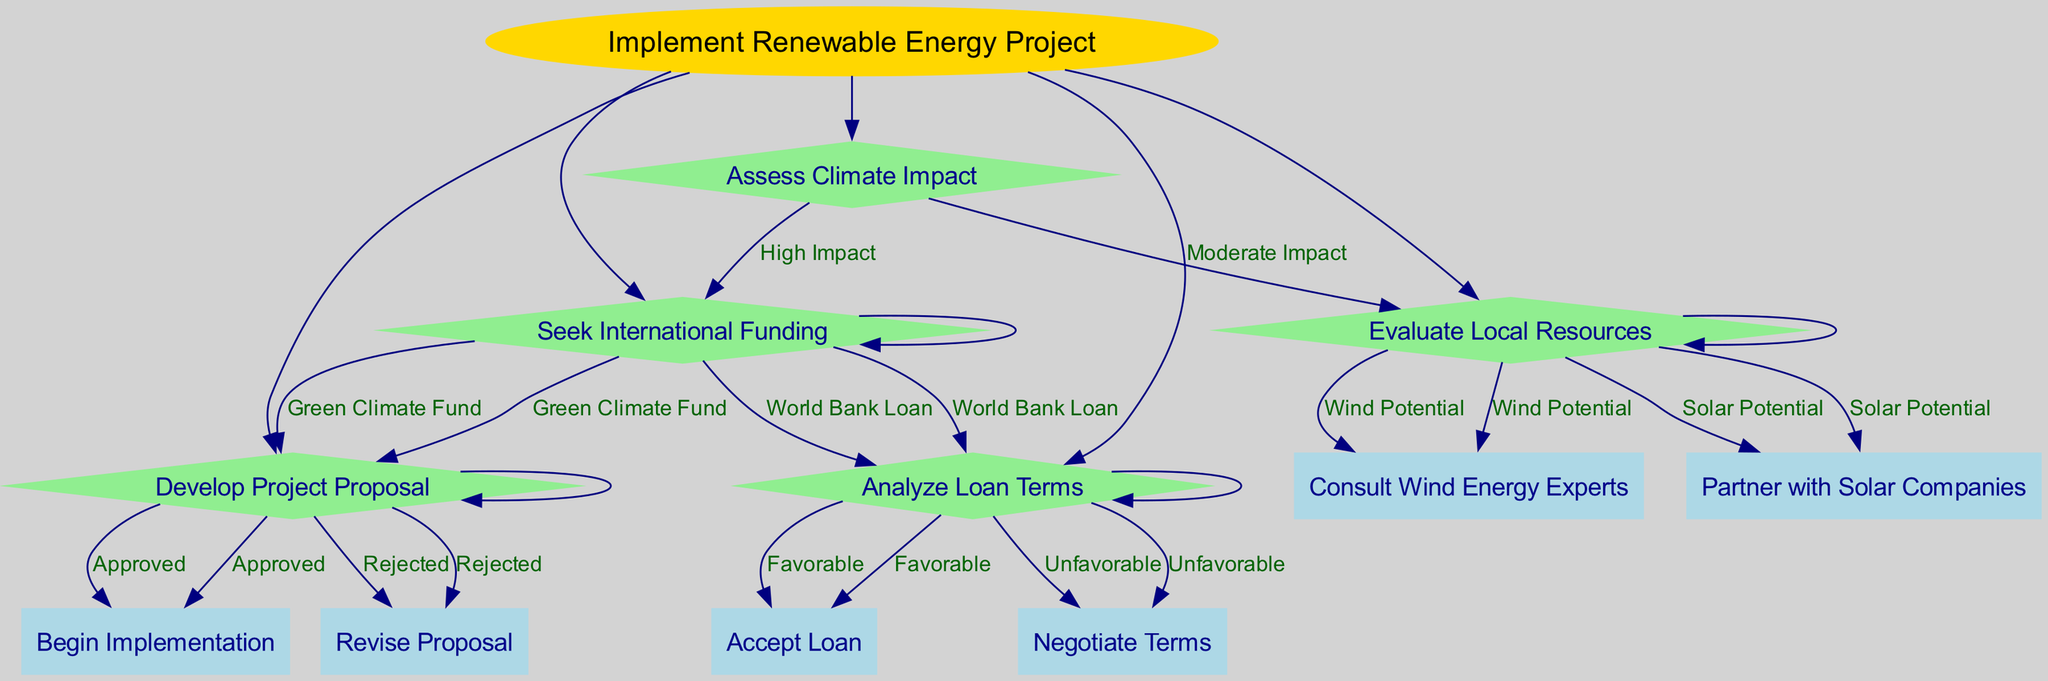What is the root node? The root node is the starting point of the decision tree, representing the initial action taken. It is labeled as "Implement Renewable Energy Project."
Answer: Implement Renewable Energy Project How many options are there under "Assess Climate Impact"? There are two options listed under "Assess Climate Impact," which discuss the level of impact and what actions to take next.
Answer: 2 What happens if the "Seek International Funding" option is selected? If "Seek International Funding" is selected, the next step is either to choose the "Green Climate Fund" leading to "Develop Project Proposal" or the "World Bank Loan" leading to "Analyze Loan Terms."
Answer: Develop Project Proposal or Analyze Loan Terms What is the next step after "Evaluate Local Resources" if "Wind Potential" is prioritized? If "Wind Potential" is prioritized after "Evaluate Local Resources," the next step is to "Consult Wind Energy Experts."
Answer: Consult Wind Energy Experts What decision follows if the "Green Climate Fund" is chosen? Choosing the "Green Climate Fund" leads to the next decision point, which is "Develop Project Proposal."
Answer: Develop Project Proposal What does the "Analyze Loan Terms" node lead to if the terms are "Favorable"? If the loan terms analyzed are "Favorable," the process moves forward to "Accept Loan."
Answer: Accept Loan If a proposal is "Rejected," what is the next action? If the project proposal is rejected, the subsequent action required is to "Revise Proposal."
Answer: Revise Proposal What is the consequence of a "High Impact" assessment during the climate impact evaluation? A "High Impact" assessment leads to the action of "Seek International Funding."
Answer: Seek International Funding What are the actions allowed after "Begin Implementation"? There are no further actions or nodes indicated after "Begin Implementation"; it is the final step in this path.
Answer: None 